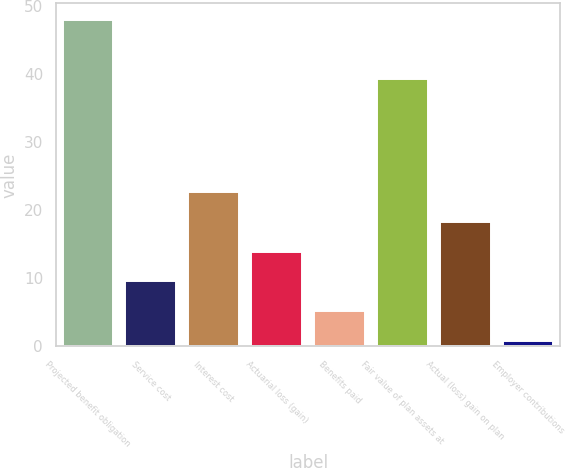<chart> <loc_0><loc_0><loc_500><loc_500><bar_chart><fcel>Projected benefit obligation<fcel>Service cost<fcel>Interest cost<fcel>Actuarial loss (gain)<fcel>Benefits paid<fcel>Fair value of plan assets at<fcel>Actual (loss) gain on plan<fcel>Employer contributions<nl><fcel>48.01<fcel>9.54<fcel>22.65<fcel>13.91<fcel>5.17<fcel>39.27<fcel>18.28<fcel>0.8<nl></chart> 